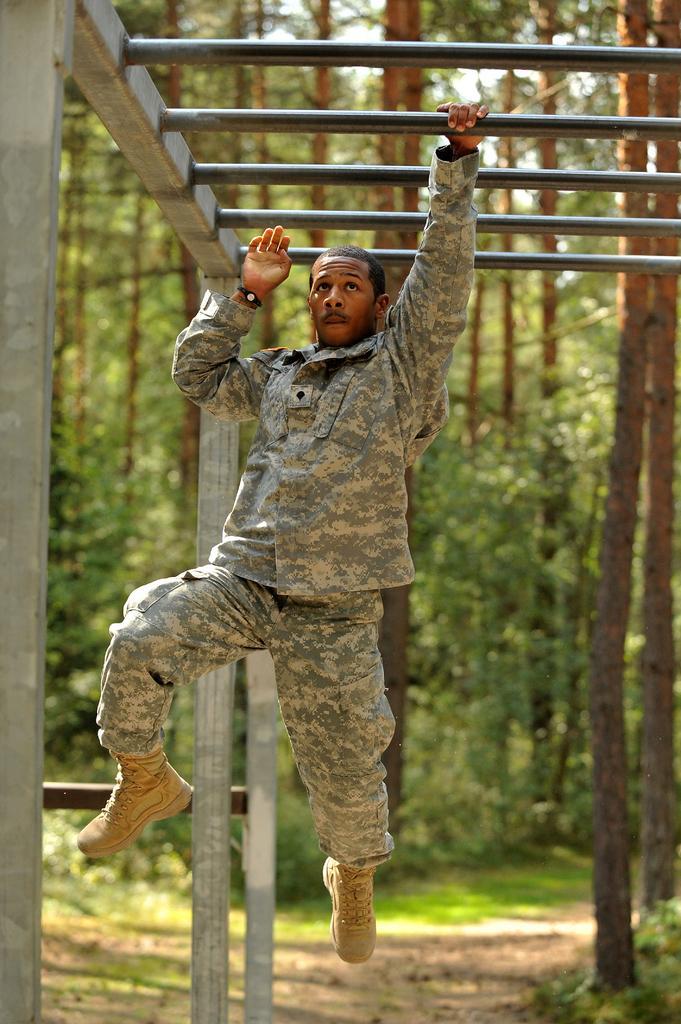Describe this image in one or two sentences. In this image I can see the person holding the rod and the person is wearing military uniform. In the background I can see few trees in green color and the sky is in white color. 